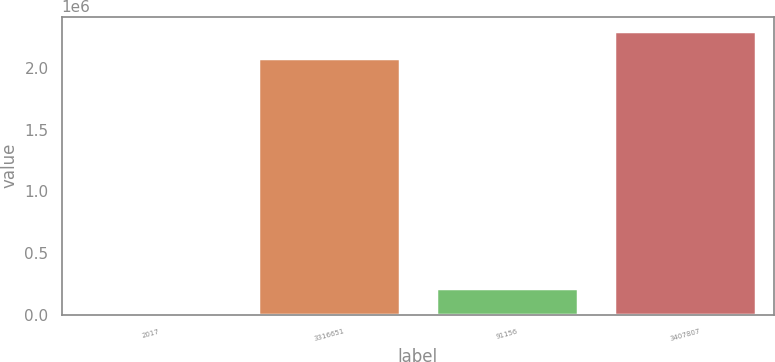Convert chart to OTSL. <chart><loc_0><loc_0><loc_500><loc_500><bar_chart><fcel>2017<fcel>3316651<fcel>91156<fcel>3407807<nl><fcel>2016<fcel>2.08421e+06<fcel>219148<fcel>2.30134e+06<nl></chart> 